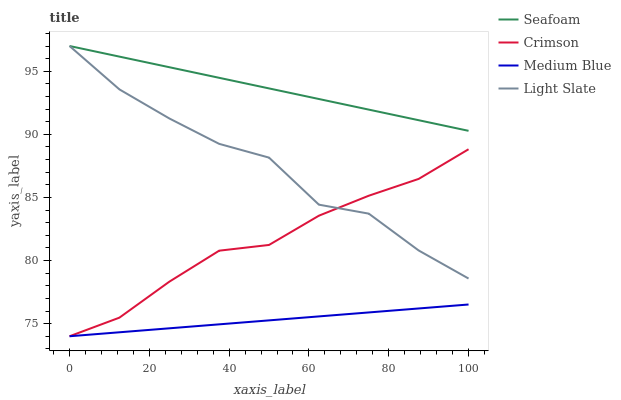Does Medium Blue have the minimum area under the curve?
Answer yes or no. Yes. Does Seafoam have the maximum area under the curve?
Answer yes or no. Yes. Does Light Slate have the minimum area under the curve?
Answer yes or no. No. Does Light Slate have the maximum area under the curve?
Answer yes or no. No. Is Seafoam the smoothest?
Answer yes or no. Yes. Is Light Slate the roughest?
Answer yes or no. Yes. Is Medium Blue the smoothest?
Answer yes or no. No. Is Medium Blue the roughest?
Answer yes or no. No. Does Light Slate have the lowest value?
Answer yes or no. No. Does Seafoam have the highest value?
Answer yes or no. Yes. Does Medium Blue have the highest value?
Answer yes or no. No. Is Medium Blue less than Seafoam?
Answer yes or no. Yes. Is Light Slate greater than Medium Blue?
Answer yes or no. Yes. Does Medium Blue intersect Seafoam?
Answer yes or no. No. 